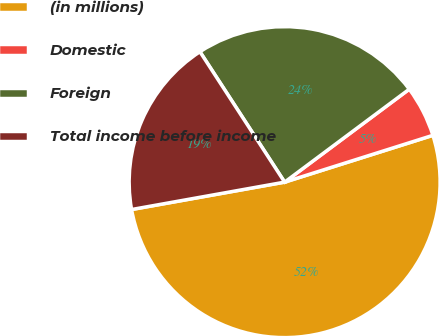Convert chart to OTSL. <chart><loc_0><loc_0><loc_500><loc_500><pie_chart><fcel>(in millions)<fcel>Domestic<fcel>Foreign<fcel>Total income before income<nl><fcel>52.05%<fcel>5.33%<fcel>23.97%<fcel>18.65%<nl></chart> 